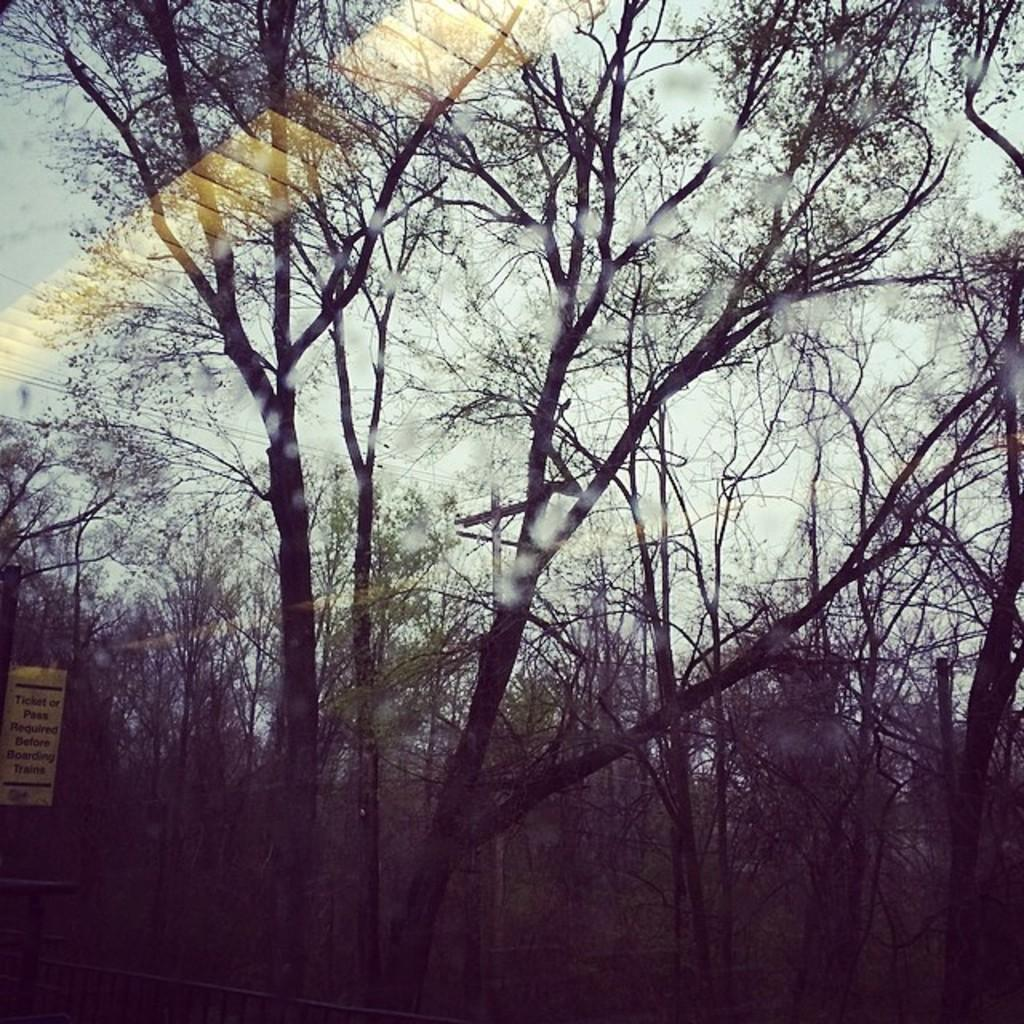What type of natural elements can be seen in the image? There are trees in the image. What type of infrastructure is present in the image? There are wires connected to a pole in the image. What type of signage or information is present in the image? There is a board with text in the image. What type of barrier or enclosure can be seen in the image? There is a fence in the image. What type of calendar is hanging on the fence in the image? There is no calendar present in the image; it features trees, wires connected to a pole, a board with text, and a fence. What type of engine can be seen powering the wires in the image? There is no engine present in the image; the wires are connected to a pole. 